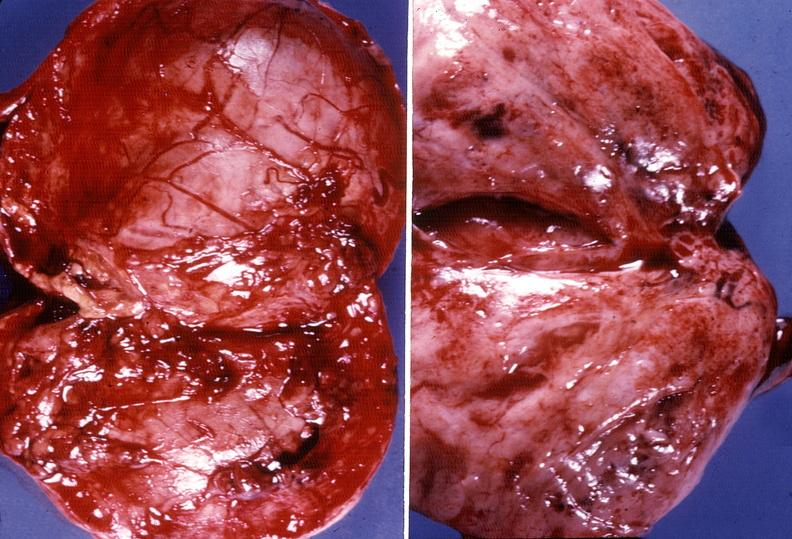does this image show adrenal phaeochromocytoma?
Answer the question using a single word or phrase. Yes 